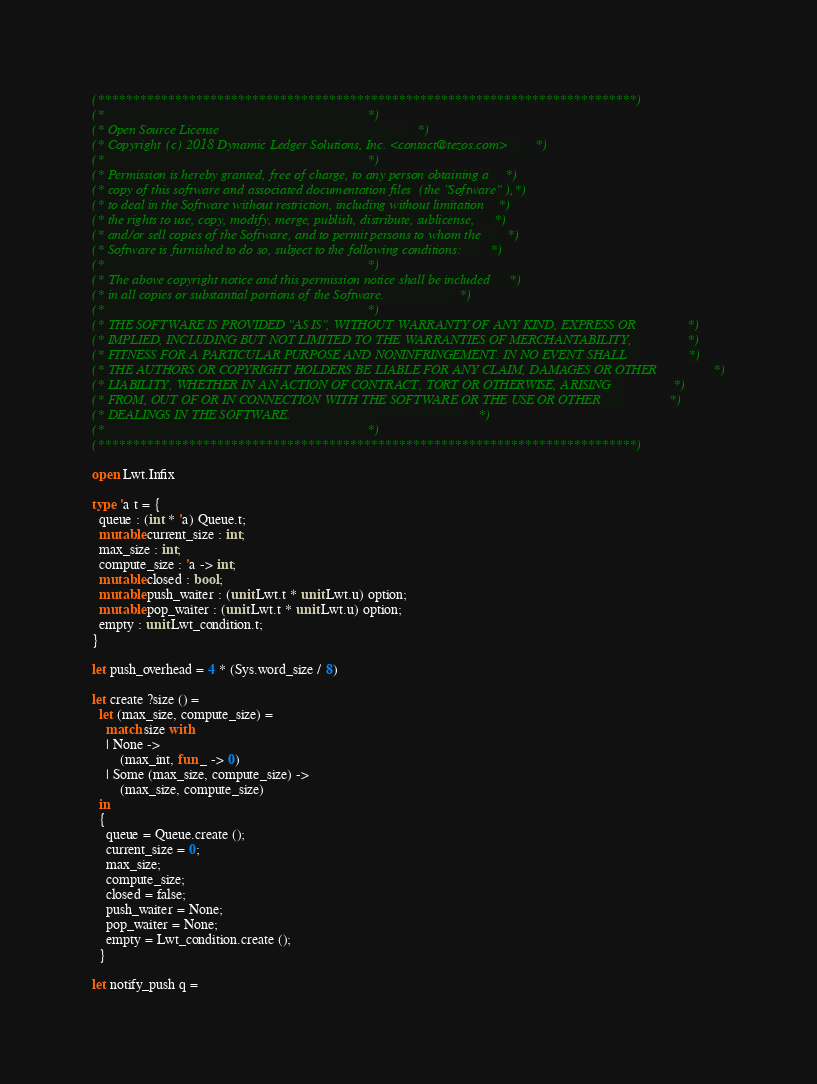<code> <loc_0><loc_0><loc_500><loc_500><_OCaml_>(*****************************************************************************)
(*                                                                           *)
(* Open Source License                                                       *)
(* Copyright (c) 2018 Dynamic Ledger Solutions, Inc. <contact@tezos.com>     *)
(*                                                                           *)
(* Permission is hereby granted, free of charge, to any person obtaining a   *)
(* copy of this software and associated documentation files (the "Software"),*)
(* to deal in the Software without restriction, including without limitation *)
(* the rights to use, copy, modify, merge, publish, distribute, sublicense,  *)
(* and/or sell copies of the Software, and to permit persons to whom the     *)
(* Software is furnished to do so, subject to the following conditions:      *)
(*                                                                           *)
(* The above copyright notice and this permission notice shall be included   *)
(* in all copies or substantial portions of the Software.                    *)
(*                                                                           *)
(* THE SOFTWARE IS PROVIDED "AS IS", WITHOUT WARRANTY OF ANY KIND, EXPRESS OR*)
(* IMPLIED, INCLUDING BUT NOT LIMITED TO THE WARRANTIES OF MERCHANTABILITY,  *)
(* FITNESS FOR A PARTICULAR PURPOSE AND NONINFRINGEMENT. IN NO EVENT SHALL   *)
(* THE AUTHORS OR COPYRIGHT HOLDERS BE LIABLE FOR ANY CLAIM, DAMAGES OR OTHER*)
(* LIABILITY, WHETHER IN AN ACTION OF CONTRACT, TORT OR OTHERWISE, ARISING   *)
(* FROM, OUT OF OR IN CONNECTION WITH THE SOFTWARE OR THE USE OR OTHER       *)
(* DEALINGS IN THE SOFTWARE.                                                 *)
(*                                                                           *)
(*****************************************************************************)

open Lwt.Infix

type 'a t = {
  queue : (int * 'a) Queue.t;
  mutable current_size : int;
  max_size : int;
  compute_size : 'a -> int;
  mutable closed : bool;
  mutable push_waiter : (unit Lwt.t * unit Lwt.u) option;
  mutable pop_waiter : (unit Lwt.t * unit Lwt.u) option;
  empty : unit Lwt_condition.t;
}

let push_overhead = 4 * (Sys.word_size / 8)

let create ?size () =
  let (max_size, compute_size) =
    match size with
    | None ->
        (max_int, fun _ -> 0)
    | Some (max_size, compute_size) ->
        (max_size, compute_size)
  in
  {
    queue = Queue.create ();
    current_size = 0;
    max_size;
    compute_size;
    closed = false;
    push_waiter = None;
    pop_waiter = None;
    empty = Lwt_condition.create ();
  }

let notify_push q =</code> 